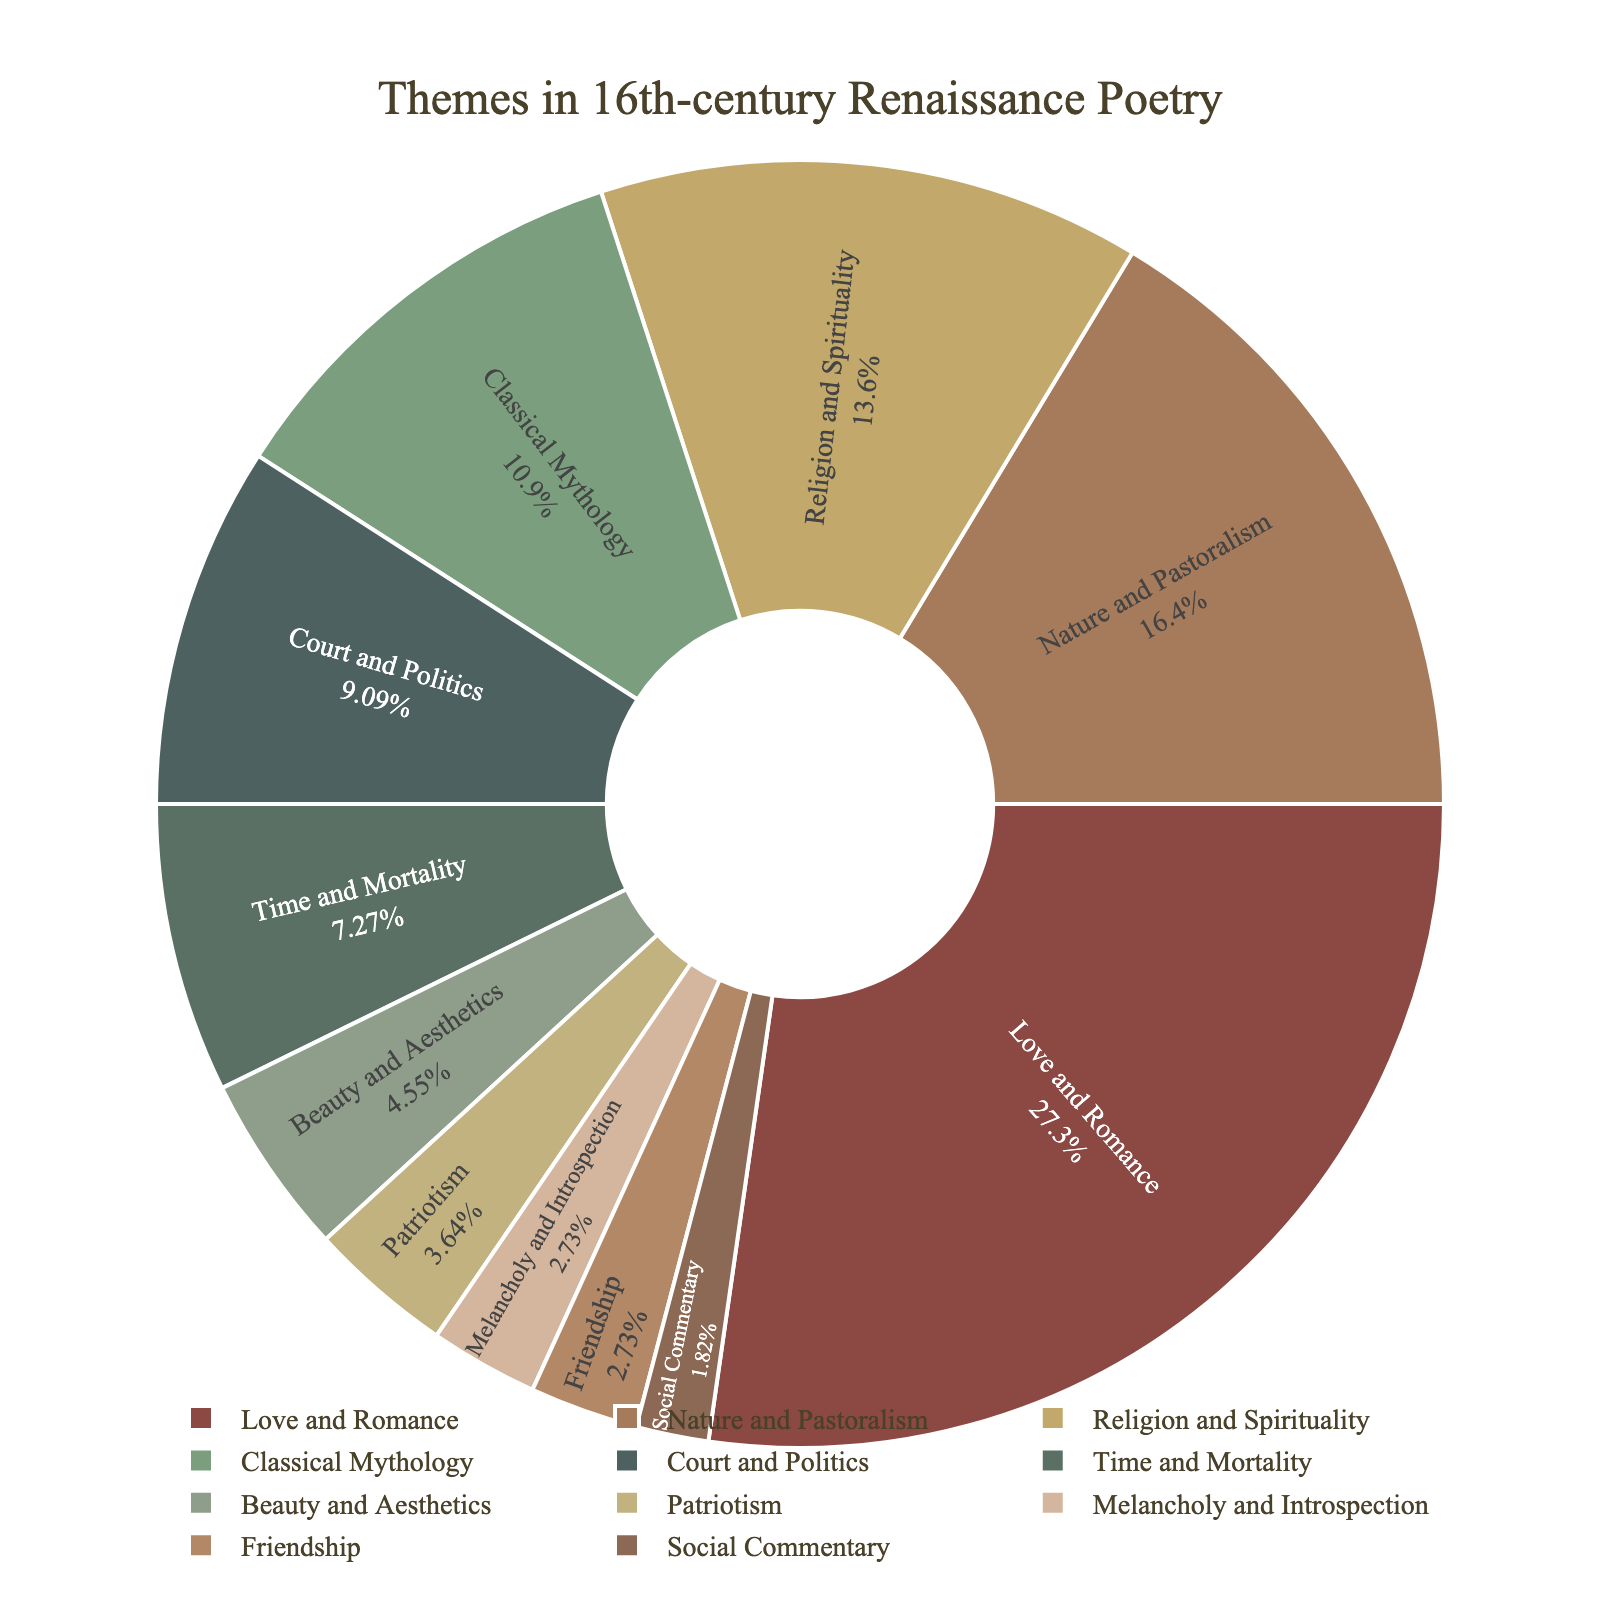What's the most prevalent theme in 16th-century Renaissance poetry according to the chart? The largest section of the pie chart represents the most prevalent theme. The "Love and Romance" section is the largest, occupying 30% of the pie chart.
Answer: Love and Romance Which theme occupies the smallest percentage of the pie chart? The smallest segment of the pie chart corresponds to the smallest percentage. Both "Social Commentary" and "Friendship" occupy the smallest segments at 2% and 3%, respectively.
Answer: Social Commentary What is the combined percentage of "Religion and Spirituality" and "Nature and Pastoralism"? To find the combined percentage, add the individual percentages of "Religion and Spirituality" (15%) and "Nature and Pastoralism" (18%).
Answer: 33% Is the percentage of "Classical Mythology" greater than or less than "Court and Politics"? Compare the percentages of "Classical Mythology" (12%) and "Court and Politics" (10%).
Answer: Greater Which themes together make up more than half (over 50%) of the pie chart? Determine the themes with the highest percentages and sum their values until the total exceeds 50%. "Love and Romance" (30%), "Nature and Pastoralism" (18%), and "Religion and Spirituality" (15%) together make up 63%.
Answer: Love and Romance, Nature and Pastoralism, Religion and Spirituality How does the percentage of "Patriotism" compare to that of "Beauty and Aesthetics"? Compare the percentages of "Patriotism" (4%) and "Beauty and Aesthetics" (5%).
Answer: Less What are the themes with percentages that fall between 10% and 20%? Identify the themes with percentages in the specified range: "Nature and Pastoralism" (18%), "Religion and Spirituality" (15%), and "Classical Mythology" (12%).
Answer: Nature and Pastoralism, Religion and Spirituality, Classical Mythology What's the total percentage of the themes that are less than 10%? Sum the percentages of themes with less than 10%: "Court and Politics" (10%), "Time and Mortality" (8%), "Beauty and Aesthetics" (5%), "Patriotism" (4%), "Melancholy and Introspection" (3%), "Friendship" (3%), and "Social Commentary" (2%). The total is 35%.
Answer: 35% 